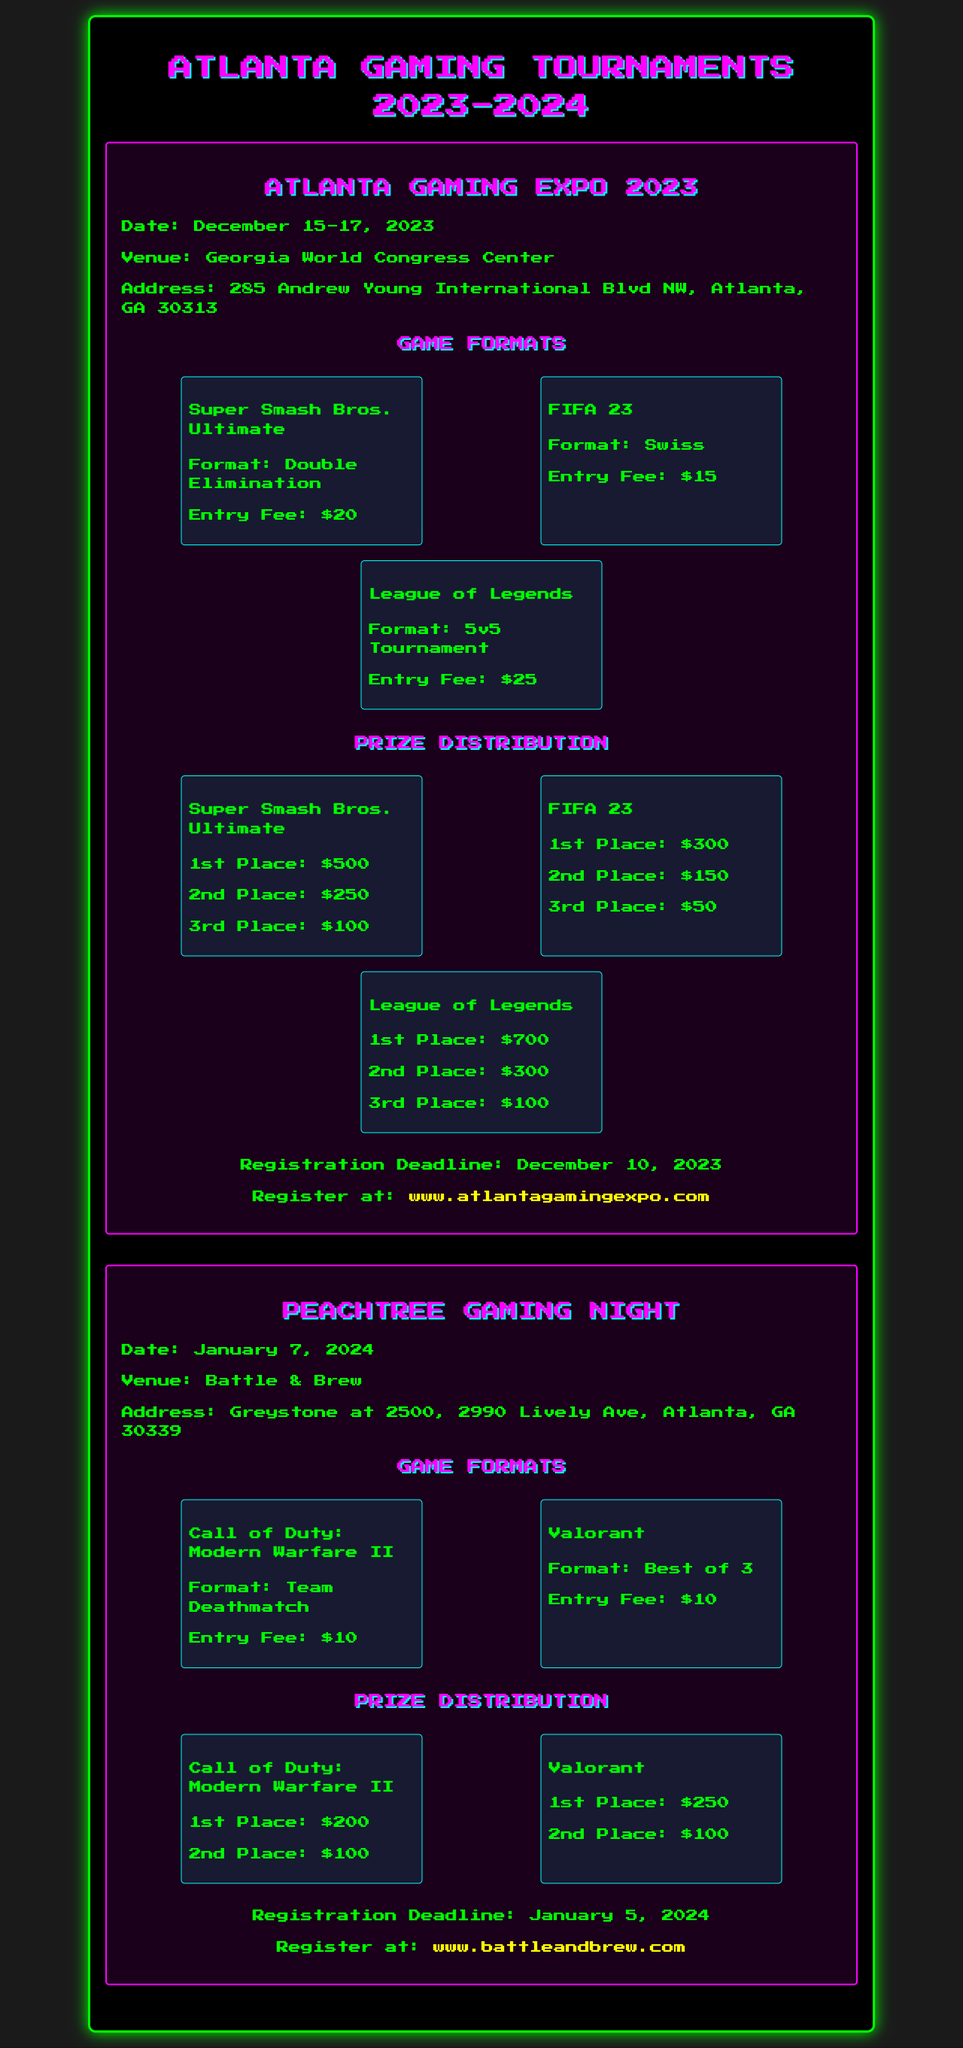What is the date of the Atlanta Gaming Expo? The date is mentioned in the document, which states December 15-17, 2023.
Answer: December 15-17, 2023 What is the entry fee for FIFA 23? The entry fee for FIFA 23 is specified under game formats in the document.
Answer: $15 Where is the Peachtree Gaming Night held? The venue is described in the document, which states it takes place at Battle & Brew.
Answer: Battle & Brew How much is the 1st place prize for League of Legends? The prize distribution for League of Legends lists the 1st place amount in the document.
Answer: $700 What is the registration deadline for the Atlanta Gaming Expo? The registration deadline is clearly stated in the registration section of the document.
Answer: December 10, 2023 What game format is used for Super Smash Bros. Ultimate? The format is provided under game formats in the document.
Answer: Double Elimination How much is the total prize for Call of Duty: Modern Warfare II? The total prize is the sum of 1st and 2nd place prizes listed in the document.
Answer: $300 How many games are listed for the Atlanta Gaming Expo? The number of games can be counted from the game formats section in the document.
Answer: 3 What type of tournament is FIFA 23 played in? The document specifies the format type for FIFA 23 in the game formats section.
Answer: Swiss 